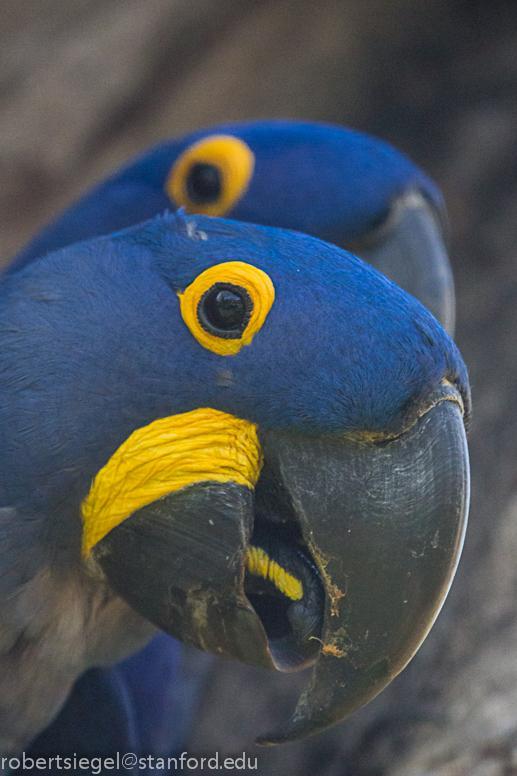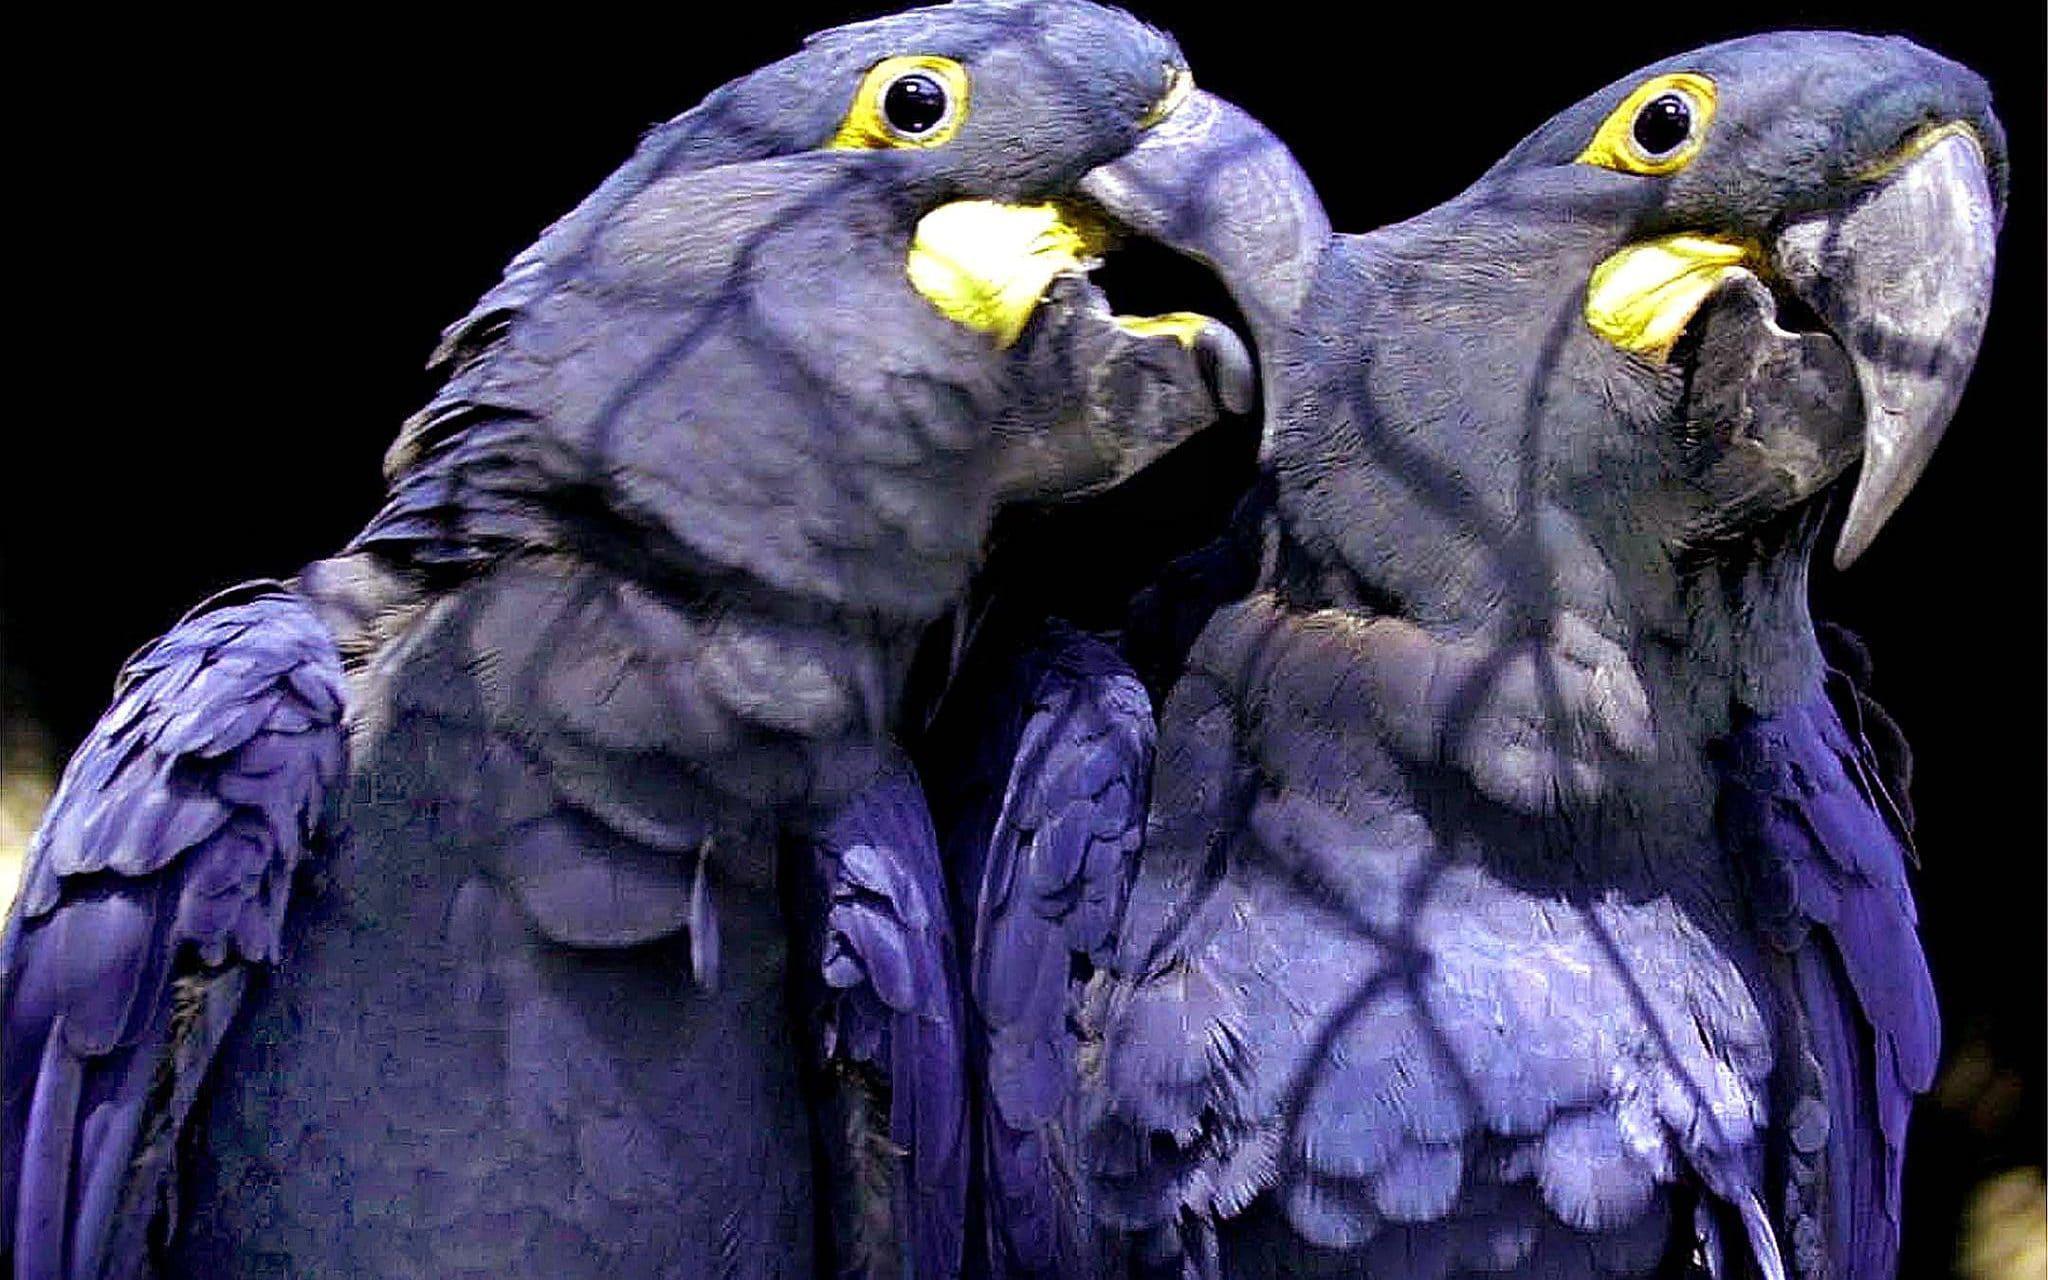The first image is the image on the left, the second image is the image on the right. Assess this claim about the two images: "There are three blue parrots.". Correct or not? Answer yes or no. No. The first image is the image on the left, the second image is the image on the right. Given the left and right images, does the statement "One image contains twice as many blue parrots as the other image, and an image shows two birds perched on something made of wood." hold true? Answer yes or no. No. 